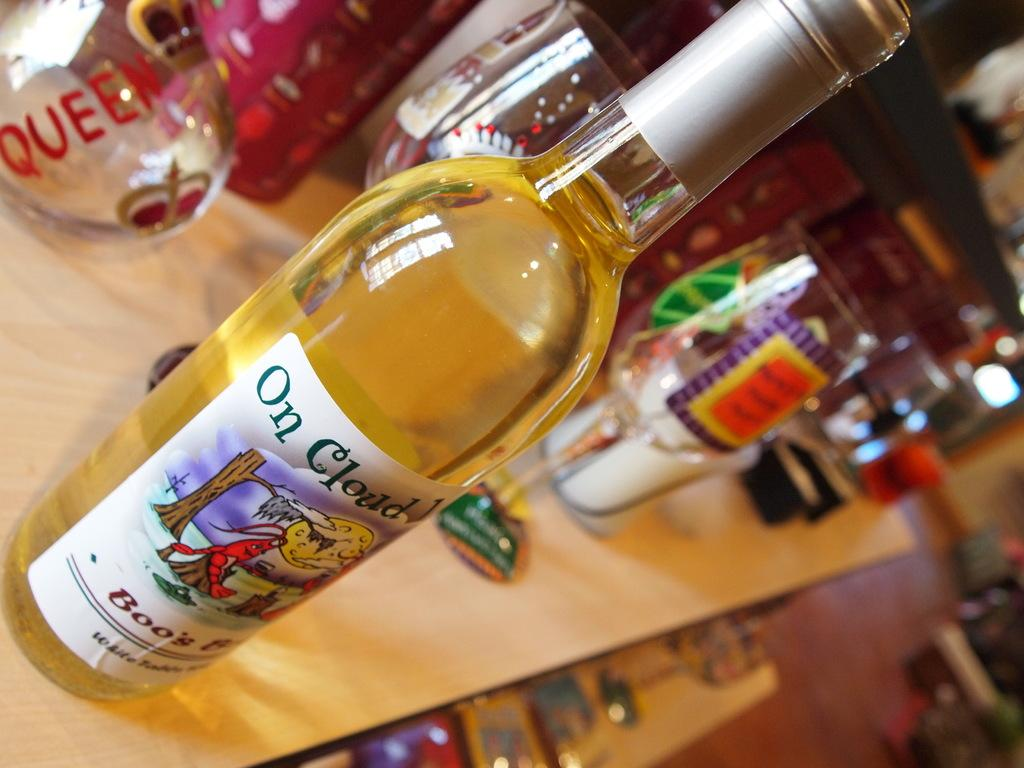<image>
Relay a brief, clear account of the picture shown. A bottle of On Cloud Wine sits on a table with a variety of glasses 